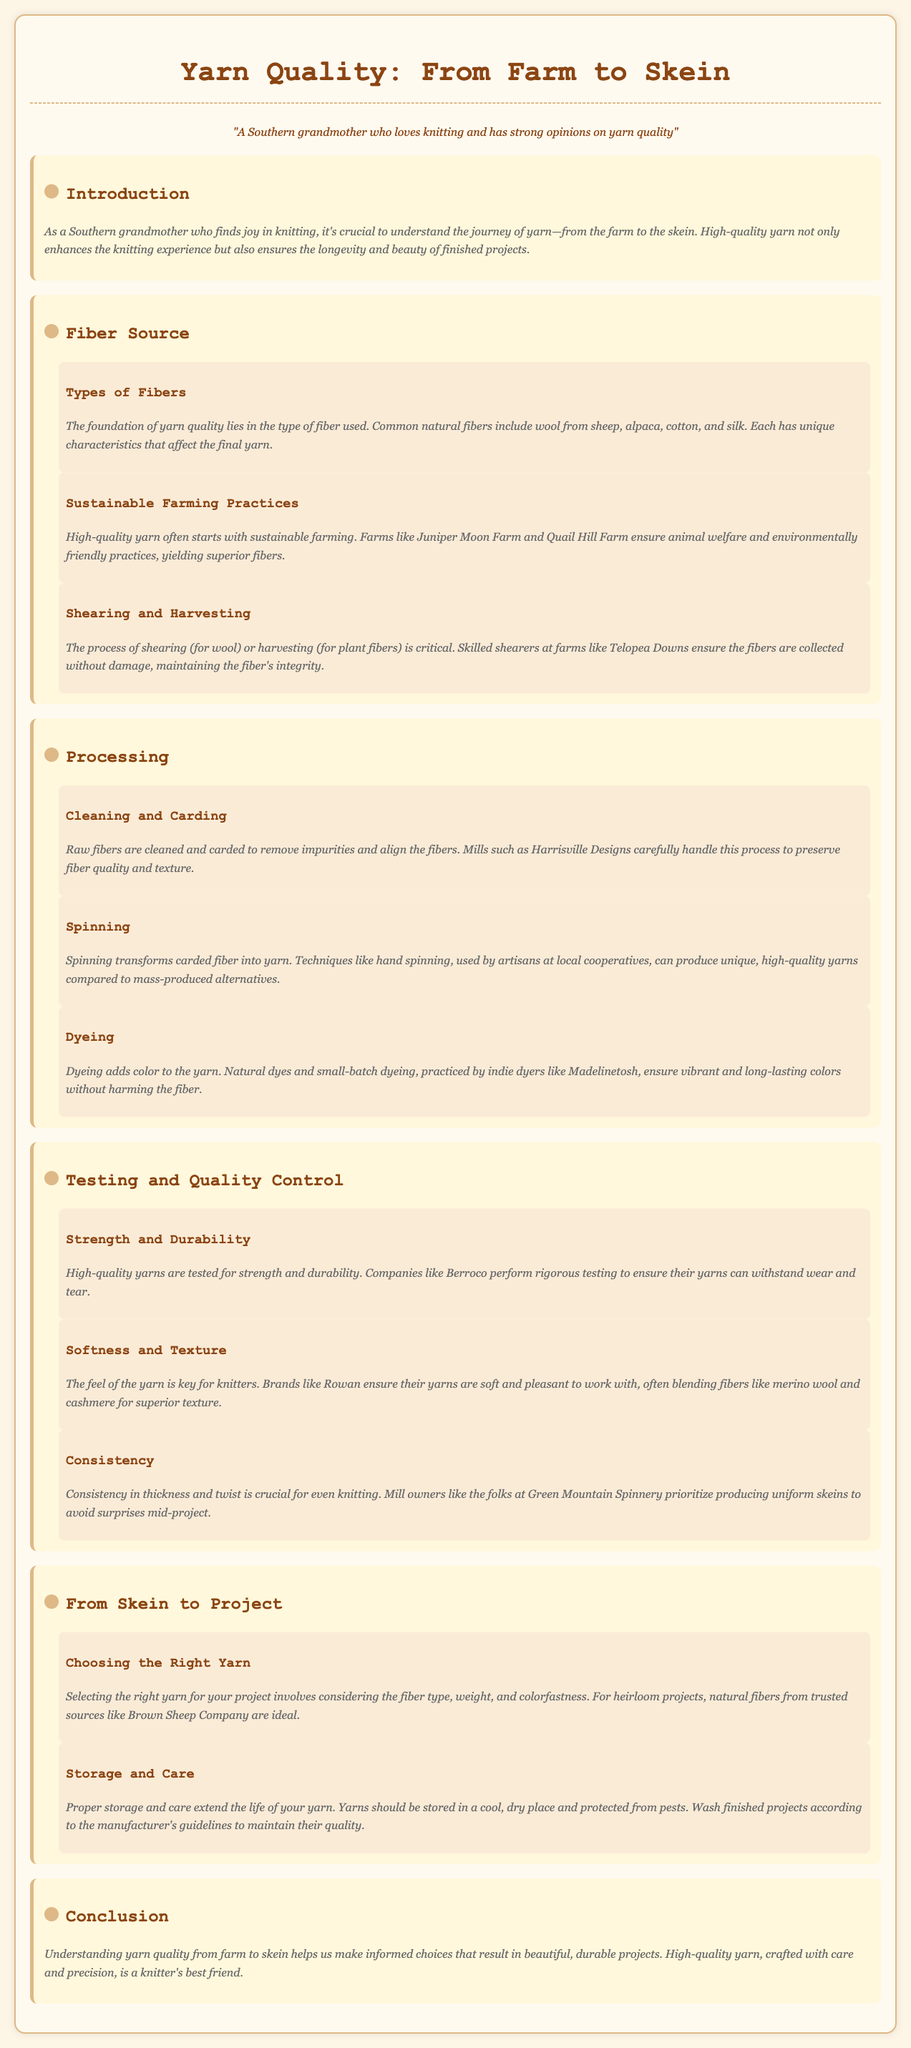What is the title of the document? The title of the document is stated clearly at the top, summarizing the main topic.
Answer: Yarn Quality: From Farm to Skein What natural fiber is commonly used for yarn? The document lists several common natural fibers, one of which is wool.
Answer: Wool Which farm is mentioned for sustainable farming practices? The document highlights specific farms known for their sustainable practices, including Juniper Moon Farm.
Answer: Juniper Moon Farm What process transforms carded fiber into yarn? The document describes spinning as the key process that changes carded fiber into yarn.
Answer: Spinning Which testing aspect ensures yarn can withstand wear? The document talks about how high-quality yarns are tested for various aspects, with strength being one of them.
Answer: Strength What is crucial for even knitting according to the document? The document emphasizes that consistency in thickness and twist is essential for even knitting.
Answer: Consistency What is recommended for storing yarn? The document advises storing yarn in a cool, dry place to extend its life.
Answer: Cool, dry place Who produces high-quality yarns tested for strength and durability? The document mentions companies that perform testing, including Berroco.
Answer: Berroco What is the importance of understanding yarn quality? The document states that understanding yarn quality helps in making informed choices for better projects.
Answer: Informed choices 